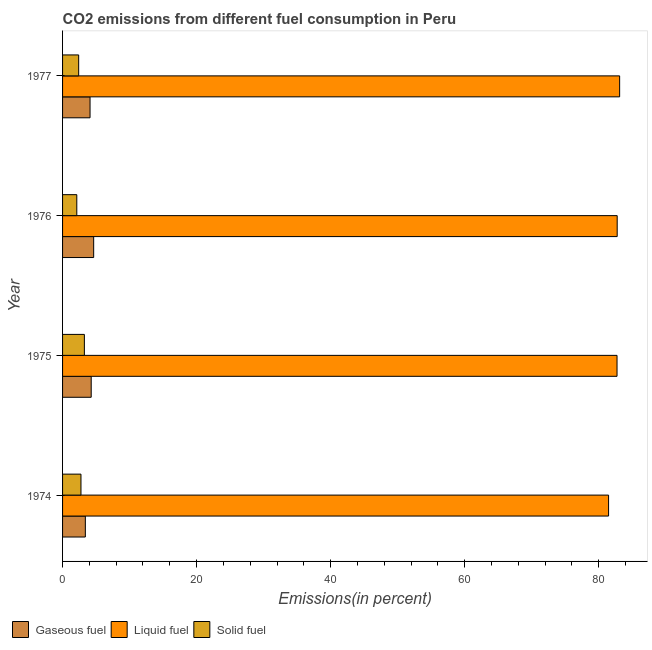How many different coloured bars are there?
Provide a short and direct response. 3. Are the number of bars per tick equal to the number of legend labels?
Your answer should be compact. Yes. How many bars are there on the 3rd tick from the top?
Ensure brevity in your answer.  3. How many bars are there on the 1st tick from the bottom?
Offer a very short reply. 3. What is the label of the 1st group of bars from the top?
Provide a short and direct response. 1977. What is the percentage of liquid fuel emission in 1977?
Offer a terse response. 83.13. Across all years, what is the maximum percentage of liquid fuel emission?
Provide a succinct answer. 83.13. Across all years, what is the minimum percentage of gaseous fuel emission?
Your answer should be very brief. 3.4. In which year was the percentage of solid fuel emission maximum?
Give a very brief answer. 1975. In which year was the percentage of liquid fuel emission minimum?
Your response must be concise. 1974. What is the total percentage of liquid fuel emission in the graph?
Your answer should be compact. 330.1. What is the difference between the percentage of liquid fuel emission in 1975 and that in 1976?
Offer a very short reply. -0.02. What is the difference between the percentage of liquid fuel emission in 1974 and the percentage of gaseous fuel emission in 1975?
Your answer should be compact. 77.2. What is the average percentage of liquid fuel emission per year?
Your answer should be very brief. 82.53. In the year 1974, what is the difference between the percentage of liquid fuel emission and percentage of solid fuel emission?
Ensure brevity in your answer.  78.73. In how many years, is the percentage of gaseous fuel emission greater than 72 %?
Your answer should be very brief. 0. What is the ratio of the percentage of liquid fuel emission in 1974 to that in 1977?
Provide a succinct answer. 0.98. Is the percentage of gaseous fuel emission in 1975 less than that in 1977?
Keep it short and to the point. No. What is the difference between the highest and the second highest percentage of liquid fuel emission?
Keep it short and to the point. 0.36. What is the difference between the highest and the lowest percentage of solid fuel emission?
Your answer should be compact. 1.13. Is the sum of the percentage of gaseous fuel emission in 1974 and 1976 greater than the maximum percentage of solid fuel emission across all years?
Ensure brevity in your answer.  Yes. What does the 3rd bar from the top in 1976 represents?
Provide a succinct answer. Gaseous fuel. What does the 2nd bar from the bottom in 1974 represents?
Your response must be concise. Liquid fuel. Is it the case that in every year, the sum of the percentage of gaseous fuel emission and percentage of liquid fuel emission is greater than the percentage of solid fuel emission?
Your answer should be compact. Yes. How many bars are there?
Make the answer very short. 12. How many years are there in the graph?
Your answer should be compact. 4. Does the graph contain grids?
Give a very brief answer. No. Where does the legend appear in the graph?
Offer a very short reply. Bottom left. How many legend labels are there?
Ensure brevity in your answer.  3. How are the legend labels stacked?
Provide a succinct answer. Horizontal. What is the title of the graph?
Offer a terse response. CO2 emissions from different fuel consumption in Peru. What is the label or title of the X-axis?
Offer a terse response. Emissions(in percent). What is the label or title of the Y-axis?
Your answer should be compact. Year. What is the Emissions(in percent) of Gaseous fuel in 1974?
Ensure brevity in your answer.  3.4. What is the Emissions(in percent) of Liquid fuel in 1974?
Your response must be concise. 81.48. What is the Emissions(in percent) in Solid fuel in 1974?
Give a very brief answer. 2.75. What is the Emissions(in percent) of Gaseous fuel in 1975?
Your answer should be compact. 4.27. What is the Emissions(in percent) in Liquid fuel in 1975?
Your response must be concise. 82.74. What is the Emissions(in percent) in Solid fuel in 1975?
Give a very brief answer. 3.26. What is the Emissions(in percent) in Gaseous fuel in 1976?
Offer a terse response. 4.64. What is the Emissions(in percent) in Liquid fuel in 1976?
Ensure brevity in your answer.  82.76. What is the Emissions(in percent) of Solid fuel in 1976?
Keep it short and to the point. 2.12. What is the Emissions(in percent) of Gaseous fuel in 1977?
Your response must be concise. 4.1. What is the Emissions(in percent) in Liquid fuel in 1977?
Offer a very short reply. 83.13. What is the Emissions(in percent) in Solid fuel in 1977?
Make the answer very short. 2.4. Across all years, what is the maximum Emissions(in percent) of Gaseous fuel?
Provide a short and direct response. 4.64. Across all years, what is the maximum Emissions(in percent) of Liquid fuel?
Offer a very short reply. 83.13. Across all years, what is the maximum Emissions(in percent) in Solid fuel?
Your response must be concise. 3.26. Across all years, what is the minimum Emissions(in percent) in Gaseous fuel?
Provide a short and direct response. 3.4. Across all years, what is the minimum Emissions(in percent) in Liquid fuel?
Ensure brevity in your answer.  81.48. Across all years, what is the minimum Emissions(in percent) of Solid fuel?
Your response must be concise. 2.12. What is the total Emissions(in percent) in Gaseous fuel in the graph?
Your answer should be very brief. 16.41. What is the total Emissions(in percent) of Liquid fuel in the graph?
Offer a terse response. 330.1. What is the total Emissions(in percent) in Solid fuel in the graph?
Give a very brief answer. 10.53. What is the difference between the Emissions(in percent) of Gaseous fuel in 1974 and that in 1975?
Give a very brief answer. -0.87. What is the difference between the Emissions(in percent) of Liquid fuel in 1974 and that in 1975?
Give a very brief answer. -1.26. What is the difference between the Emissions(in percent) of Solid fuel in 1974 and that in 1975?
Your answer should be very brief. -0.51. What is the difference between the Emissions(in percent) of Gaseous fuel in 1974 and that in 1976?
Offer a terse response. -1.24. What is the difference between the Emissions(in percent) in Liquid fuel in 1974 and that in 1976?
Offer a terse response. -1.28. What is the difference between the Emissions(in percent) of Solid fuel in 1974 and that in 1976?
Provide a succinct answer. 0.62. What is the difference between the Emissions(in percent) of Gaseous fuel in 1974 and that in 1977?
Provide a succinct answer. -0.7. What is the difference between the Emissions(in percent) in Liquid fuel in 1974 and that in 1977?
Keep it short and to the point. -1.65. What is the difference between the Emissions(in percent) in Solid fuel in 1974 and that in 1977?
Give a very brief answer. 0.34. What is the difference between the Emissions(in percent) in Gaseous fuel in 1975 and that in 1976?
Your answer should be very brief. -0.37. What is the difference between the Emissions(in percent) of Liquid fuel in 1975 and that in 1976?
Keep it short and to the point. -0.02. What is the difference between the Emissions(in percent) of Solid fuel in 1975 and that in 1976?
Your response must be concise. 1.13. What is the difference between the Emissions(in percent) in Gaseous fuel in 1975 and that in 1977?
Offer a very short reply. 0.17. What is the difference between the Emissions(in percent) of Liquid fuel in 1975 and that in 1977?
Provide a succinct answer. -0.39. What is the difference between the Emissions(in percent) in Solid fuel in 1975 and that in 1977?
Keep it short and to the point. 0.85. What is the difference between the Emissions(in percent) of Gaseous fuel in 1976 and that in 1977?
Your answer should be compact. 0.54. What is the difference between the Emissions(in percent) in Liquid fuel in 1976 and that in 1977?
Give a very brief answer. -0.36. What is the difference between the Emissions(in percent) in Solid fuel in 1976 and that in 1977?
Make the answer very short. -0.28. What is the difference between the Emissions(in percent) of Gaseous fuel in 1974 and the Emissions(in percent) of Liquid fuel in 1975?
Your answer should be compact. -79.34. What is the difference between the Emissions(in percent) of Gaseous fuel in 1974 and the Emissions(in percent) of Solid fuel in 1975?
Offer a very short reply. 0.14. What is the difference between the Emissions(in percent) of Liquid fuel in 1974 and the Emissions(in percent) of Solid fuel in 1975?
Ensure brevity in your answer.  78.22. What is the difference between the Emissions(in percent) of Gaseous fuel in 1974 and the Emissions(in percent) of Liquid fuel in 1976?
Keep it short and to the point. -79.36. What is the difference between the Emissions(in percent) of Gaseous fuel in 1974 and the Emissions(in percent) of Solid fuel in 1976?
Offer a very short reply. 1.27. What is the difference between the Emissions(in percent) of Liquid fuel in 1974 and the Emissions(in percent) of Solid fuel in 1976?
Provide a succinct answer. 79.35. What is the difference between the Emissions(in percent) of Gaseous fuel in 1974 and the Emissions(in percent) of Liquid fuel in 1977?
Make the answer very short. -79.73. What is the difference between the Emissions(in percent) of Gaseous fuel in 1974 and the Emissions(in percent) of Solid fuel in 1977?
Your response must be concise. 1. What is the difference between the Emissions(in percent) of Liquid fuel in 1974 and the Emissions(in percent) of Solid fuel in 1977?
Ensure brevity in your answer.  79.07. What is the difference between the Emissions(in percent) in Gaseous fuel in 1975 and the Emissions(in percent) in Liquid fuel in 1976?
Provide a succinct answer. -78.49. What is the difference between the Emissions(in percent) in Gaseous fuel in 1975 and the Emissions(in percent) in Solid fuel in 1976?
Keep it short and to the point. 2.15. What is the difference between the Emissions(in percent) in Liquid fuel in 1975 and the Emissions(in percent) in Solid fuel in 1976?
Offer a terse response. 80.61. What is the difference between the Emissions(in percent) in Gaseous fuel in 1975 and the Emissions(in percent) in Liquid fuel in 1977?
Give a very brief answer. -78.85. What is the difference between the Emissions(in percent) in Gaseous fuel in 1975 and the Emissions(in percent) in Solid fuel in 1977?
Give a very brief answer. 1.87. What is the difference between the Emissions(in percent) in Liquid fuel in 1975 and the Emissions(in percent) in Solid fuel in 1977?
Your answer should be compact. 80.33. What is the difference between the Emissions(in percent) in Gaseous fuel in 1976 and the Emissions(in percent) in Liquid fuel in 1977?
Offer a very short reply. -78.49. What is the difference between the Emissions(in percent) of Gaseous fuel in 1976 and the Emissions(in percent) of Solid fuel in 1977?
Ensure brevity in your answer.  2.24. What is the difference between the Emissions(in percent) of Liquid fuel in 1976 and the Emissions(in percent) of Solid fuel in 1977?
Your answer should be very brief. 80.36. What is the average Emissions(in percent) in Gaseous fuel per year?
Give a very brief answer. 4.1. What is the average Emissions(in percent) in Liquid fuel per year?
Offer a very short reply. 82.53. What is the average Emissions(in percent) of Solid fuel per year?
Offer a terse response. 2.63. In the year 1974, what is the difference between the Emissions(in percent) in Gaseous fuel and Emissions(in percent) in Liquid fuel?
Ensure brevity in your answer.  -78.08. In the year 1974, what is the difference between the Emissions(in percent) in Gaseous fuel and Emissions(in percent) in Solid fuel?
Ensure brevity in your answer.  0.65. In the year 1974, what is the difference between the Emissions(in percent) of Liquid fuel and Emissions(in percent) of Solid fuel?
Keep it short and to the point. 78.73. In the year 1975, what is the difference between the Emissions(in percent) of Gaseous fuel and Emissions(in percent) of Liquid fuel?
Provide a short and direct response. -78.46. In the year 1975, what is the difference between the Emissions(in percent) of Gaseous fuel and Emissions(in percent) of Solid fuel?
Provide a short and direct response. 1.02. In the year 1975, what is the difference between the Emissions(in percent) of Liquid fuel and Emissions(in percent) of Solid fuel?
Your answer should be compact. 79.48. In the year 1976, what is the difference between the Emissions(in percent) in Gaseous fuel and Emissions(in percent) in Liquid fuel?
Provide a succinct answer. -78.12. In the year 1976, what is the difference between the Emissions(in percent) in Gaseous fuel and Emissions(in percent) in Solid fuel?
Provide a succinct answer. 2.52. In the year 1976, what is the difference between the Emissions(in percent) in Liquid fuel and Emissions(in percent) in Solid fuel?
Offer a very short reply. 80.64. In the year 1977, what is the difference between the Emissions(in percent) of Gaseous fuel and Emissions(in percent) of Liquid fuel?
Keep it short and to the point. -79.03. In the year 1977, what is the difference between the Emissions(in percent) of Gaseous fuel and Emissions(in percent) of Solid fuel?
Provide a short and direct response. 1.7. In the year 1977, what is the difference between the Emissions(in percent) of Liquid fuel and Emissions(in percent) of Solid fuel?
Make the answer very short. 80.72. What is the ratio of the Emissions(in percent) in Gaseous fuel in 1974 to that in 1975?
Provide a short and direct response. 0.8. What is the ratio of the Emissions(in percent) of Solid fuel in 1974 to that in 1975?
Provide a short and direct response. 0.84. What is the ratio of the Emissions(in percent) of Gaseous fuel in 1974 to that in 1976?
Keep it short and to the point. 0.73. What is the ratio of the Emissions(in percent) of Liquid fuel in 1974 to that in 1976?
Keep it short and to the point. 0.98. What is the ratio of the Emissions(in percent) of Solid fuel in 1974 to that in 1976?
Provide a succinct answer. 1.29. What is the ratio of the Emissions(in percent) in Gaseous fuel in 1974 to that in 1977?
Provide a succinct answer. 0.83. What is the ratio of the Emissions(in percent) in Liquid fuel in 1974 to that in 1977?
Keep it short and to the point. 0.98. What is the ratio of the Emissions(in percent) in Solid fuel in 1974 to that in 1977?
Your answer should be compact. 1.14. What is the ratio of the Emissions(in percent) of Gaseous fuel in 1975 to that in 1976?
Make the answer very short. 0.92. What is the ratio of the Emissions(in percent) in Liquid fuel in 1975 to that in 1976?
Offer a terse response. 1. What is the ratio of the Emissions(in percent) of Solid fuel in 1975 to that in 1976?
Ensure brevity in your answer.  1.53. What is the ratio of the Emissions(in percent) of Gaseous fuel in 1975 to that in 1977?
Provide a short and direct response. 1.04. What is the ratio of the Emissions(in percent) of Solid fuel in 1975 to that in 1977?
Your answer should be very brief. 1.35. What is the ratio of the Emissions(in percent) in Gaseous fuel in 1976 to that in 1977?
Offer a terse response. 1.13. What is the ratio of the Emissions(in percent) of Solid fuel in 1976 to that in 1977?
Keep it short and to the point. 0.88. What is the difference between the highest and the second highest Emissions(in percent) of Gaseous fuel?
Give a very brief answer. 0.37. What is the difference between the highest and the second highest Emissions(in percent) of Liquid fuel?
Your answer should be compact. 0.36. What is the difference between the highest and the second highest Emissions(in percent) in Solid fuel?
Provide a short and direct response. 0.51. What is the difference between the highest and the lowest Emissions(in percent) in Gaseous fuel?
Make the answer very short. 1.24. What is the difference between the highest and the lowest Emissions(in percent) in Liquid fuel?
Offer a terse response. 1.65. What is the difference between the highest and the lowest Emissions(in percent) in Solid fuel?
Offer a terse response. 1.13. 